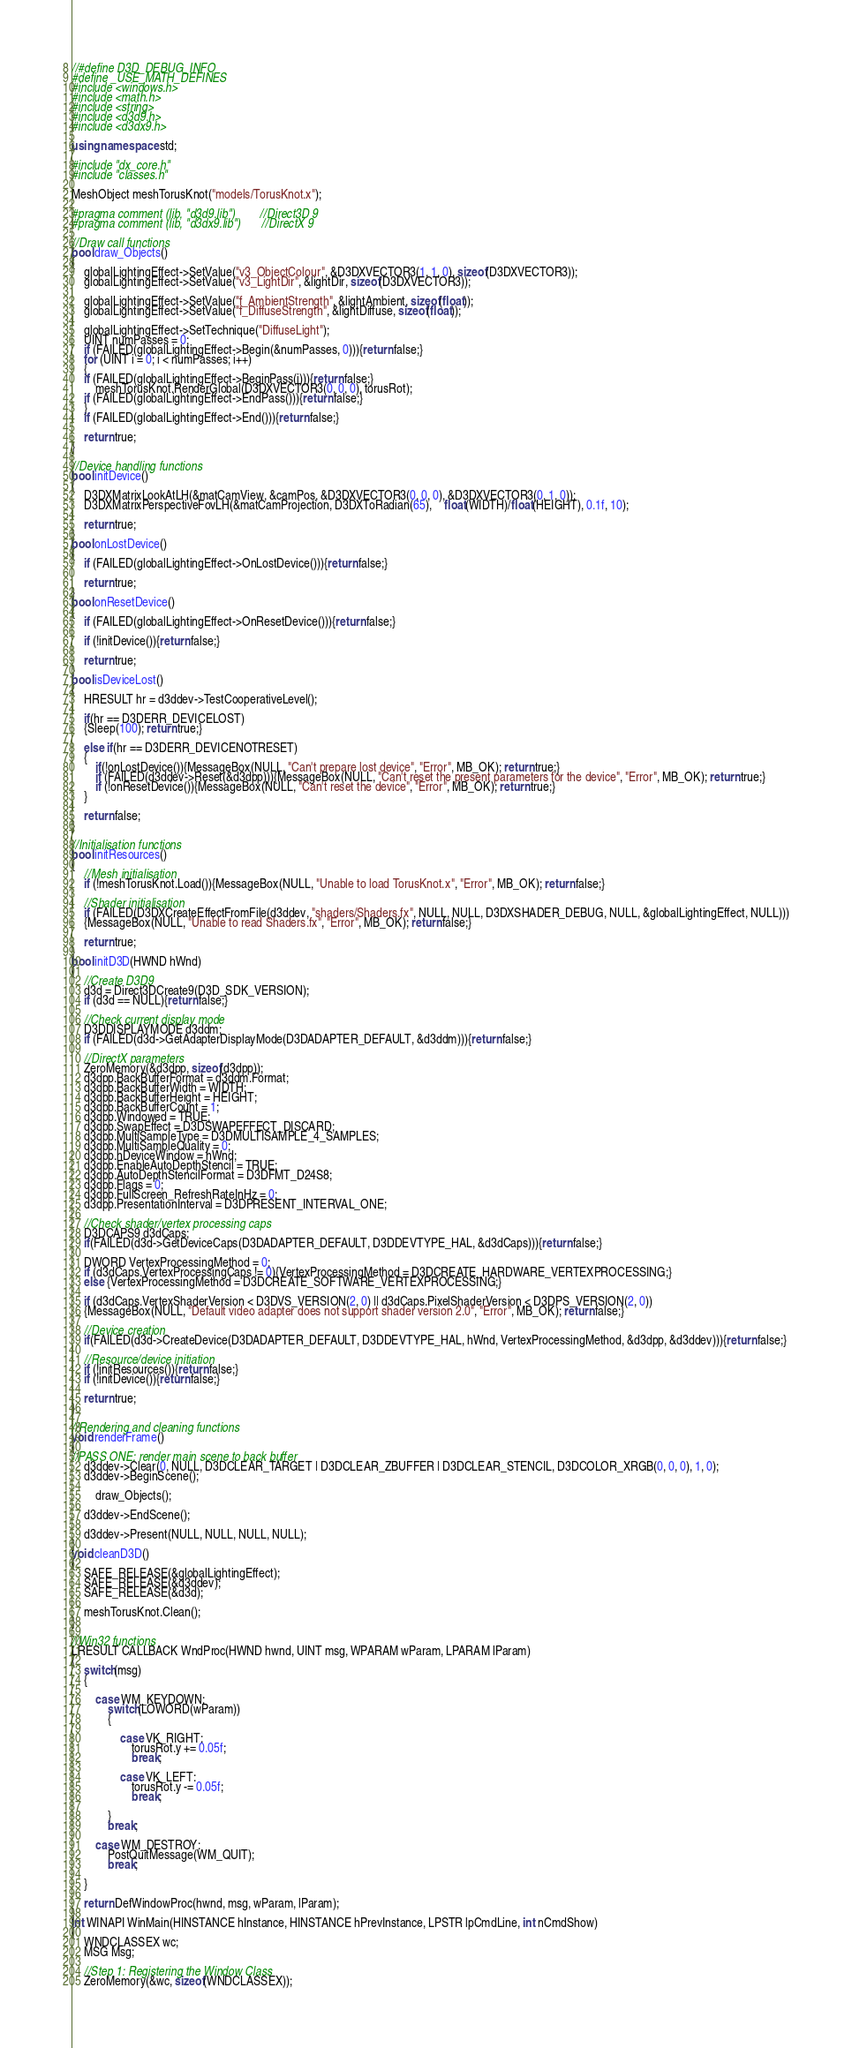Convert code to text. <code><loc_0><loc_0><loc_500><loc_500><_C++_>//#define D3D_DEBUG_INFO
#define _USE_MATH_DEFINES
#include <windows.h>
#include <math.h>
#include <string>
#include <d3d9.h>
#include <d3dx9.h>

using namespace std;

#include "dx_core.h"
#include "classes.h"

MeshObject meshTorusKnot("models/TorusKnot.x");

#pragma comment (lib, "d3d9.lib")		//Direct3D 9
#pragma comment (lib, "d3dx9.lib")		//DirectX 9

//Draw call functions
bool draw_Objects()
{
	globalLightingEffect->SetValue("v3_ObjectColour", &D3DXVECTOR3(1, 1, 0), sizeof(D3DXVECTOR3));
	globalLightingEffect->SetValue("v3_LightDir", &lightDir, sizeof(D3DXVECTOR3));

	globalLightingEffect->SetValue("f_AmbientStrength", &lightAmbient, sizeof(float));
	globalLightingEffect->SetValue("f_DiffuseStrength", &lightDiffuse, sizeof(float));

	globalLightingEffect->SetTechnique("DiffuseLight");
	UINT numPasses = 0;
	if (FAILED(globalLightingEffect->Begin(&numPasses, 0))){return false;}
	for (UINT i = 0; i < numPasses; i++)
	{
	if (FAILED(globalLightingEffect->BeginPass(i))){return false;}
		meshTorusKnot.RenderGlobal(D3DXVECTOR3(0, 0, 0), torusRot);
	if (FAILED(globalLightingEffect->EndPass())){return false;}
	}
	if (FAILED(globalLightingEffect->End())){return false;}

	return true;
}

//Device handling functions
bool initDevice()
{
	D3DXMatrixLookAtLH(&matCamView, &camPos, &D3DXVECTOR3(0, 0, 0), &D3DXVECTOR3(0, 1, 0));
	D3DXMatrixPerspectiveFovLH(&matCamProjection, D3DXToRadian(65),	float(WIDTH)/float(HEIGHT), 0.1f, 10);

	return true;
}
bool onLostDevice()
{
	if (FAILED(globalLightingEffect->OnLostDevice())){return false;}

	return true;
}
bool onResetDevice()
{
	if (FAILED(globalLightingEffect->OnResetDevice())){return false;}

	if (!initDevice()){return false;}

	return true;
}
bool isDeviceLost()
{
	HRESULT hr = d3ddev->TestCooperativeLevel();

	if(hr == D3DERR_DEVICELOST)
	{Sleep(100); return true;}

	else if(hr == D3DERR_DEVICENOTRESET)
	{
		if(!onLostDevice()){MessageBox(NULL, "Can't prepare lost device", "Error", MB_OK); return true;}
		if (FAILED(d3ddev->Reset(&d3dpp))){MessageBox(NULL, "Can't reset the present parameters for the device", "Error", MB_OK); return true;}
		if (!onResetDevice()){MessageBox(NULL, "Can't reset the device", "Error", MB_OK); return true;}
	}

	return false;
}

//Initialisation functions
bool initResources()
{
	//Mesh initialisation
	if (!meshTorusKnot.Load()){MessageBox(NULL, "Unable to load TorusKnot.x", "Error", MB_OK); return false;}

	//Shader initialisation
	if (FAILED(D3DXCreateEffectFromFile(d3ddev, "shaders/Shaders.fx", NULL, NULL, D3DXSHADER_DEBUG, NULL, &globalLightingEffect, NULL)))
	{MessageBox(NULL, "Unable to read Shaders.fx", "Error", MB_OK); return false;}

	return true;
}
bool initD3D(HWND hWnd)
{
	//Create D3D9
    d3d = Direct3DCreate9(D3D_SDK_VERSION);
	if (d3d == NULL){return false;}

	//Check current display mode
	D3DDISPLAYMODE d3ddm; 
	if (FAILED(d3d->GetAdapterDisplayMode(D3DADAPTER_DEFAULT, &d3ddm))){return false;}

	//DirectX parameters
    ZeroMemory(&d3dpp, sizeof(d3dpp));	
	d3dpp.BackBufferFormat = d3ddm.Format;				
	d3dpp.BackBufferWidth = WIDTH;							
	d3dpp.BackBufferHeight = HEIGHT;						
	d3dpp.BackBufferCount = 1;								
    d3dpp.Windowed = TRUE;								
    d3dpp.SwapEffect = D3DSWAPEFFECT_DISCARD;		
	d3dpp.MultiSampleType = D3DMULTISAMPLE_4_SAMPLES;			
	d3dpp.MultiSampleQuality = 0;						
	d3dpp.hDeviceWindow = hWnd;								
    d3dpp.EnableAutoDepthStencil = TRUE;					
	d3dpp.AutoDepthStencilFormat = D3DFMT_D24S8;			
	d3dpp.Flags = 0;									
	d3dpp.FullScreen_RefreshRateInHz = 0;					
	d3dpp.PresentationInterval = D3DPRESENT_INTERVAL_ONE; 

	//Check shader/vertex processing caps
	D3DCAPS9 d3dCaps;
	if(FAILED(d3d->GetDeviceCaps(D3DADAPTER_DEFAULT, D3DDEVTYPE_HAL, &d3dCaps))){return false;}

	DWORD VertexProcessingMethod = 0;
	if (d3dCaps.VertexProcessingCaps != 0){VertexProcessingMethod = D3DCREATE_HARDWARE_VERTEXPROCESSING;}
	else {VertexProcessingMethod = D3DCREATE_SOFTWARE_VERTEXPROCESSING;}

	if (d3dCaps.VertexShaderVersion < D3DVS_VERSION(2, 0) || d3dCaps.PixelShaderVersion < D3DPS_VERSION(2, 0))
	{MessageBox(NULL, "Default video adapter does not support shader version 2.0", "Error", MB_OK); return false;}

	//Device creation
    if(FAILED(d3d->CreateDevice(D3DADAPTER_DEFAULT, D3DDEVTYPE_HAL, hWnd, VertexProcessingMethod, &d3dpp, &d3ddev))){return false;}

	//Resource/device initiation
	if (!initResources()){return false;}
	if (!initDevice()){return false;}

	return true;
}

//Rendering and cleaning functions
void renderFrame()
{
//PASS ONE: render main scene to back buffer
	d3ddev->Clear(0, NULL, D3DCLEAR_TARGET | D3DCLEAR_ZBUFFER | D3DCLEAR_STENCIL, D3DCOLOR_XRGB(0, 0, 0), 1, 0);
	d3ddev->BeginScene();

		draw_Objects();

	d3ddev->EndScene();

	d3ddev->Present(NULL, NULL, NULL, NULL);
}
void cleanD3D()
{
	SAFE_RELEASE(&globalLightingEffect);	
	SAFE_RELEASE(&d3ddev);					
	SAFE_RELEASE(&d3d);		

	meshTorusKnot.Clean();
}

//Win32 functions
LRESULT CALLBACK WndProc(HWND hwnd, UINT msg, WPARAM wParam, LPARAM lParam)
{
	switch(msg)
    {

		case WM_KEYDOWN:
			switch(LOWORD(wParam))
			{

				case VK_RIGHT:
					torusRot.y += 0.05f;
					break;

				case VK_LEFT:
					torusRot.y -= 0.05f;
					break;

			}
			break;

        case WM_DESTROY:
            PostQuitMessage(WM_QUIT);
			break;

	}
	
	return DefWindowProc(hwnd, msg, wParam, lParam);
}
int WINAPI WinMain(HINSTANCE hInstance, HINSTANCE hPrevInstance, LPSTR lpCmdLine, int nCmdShow)
{
    WNDCLASSEX wc;
    MSG Msg;

    //Step 1: Registering the Window Class
    ZeroMemory(&wc, sizeof(WNDCLASSEX));
</code> 